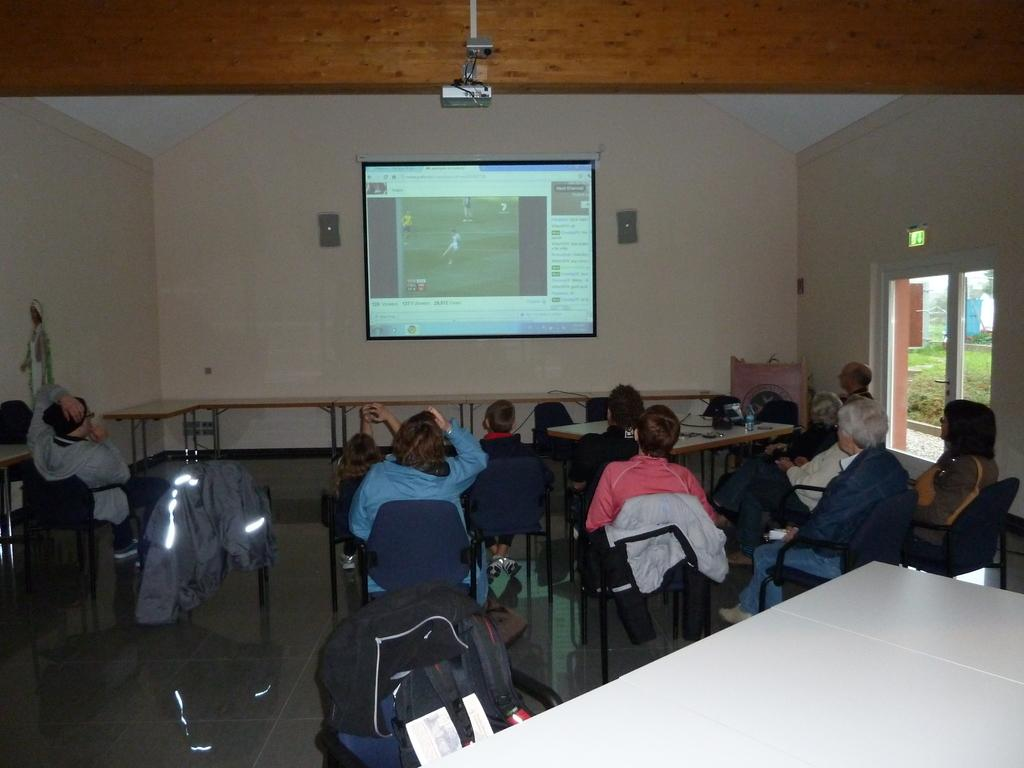What are the people in the image doing? The people in the image are sitting on chairs. What device is present in the image for displaying visuals? There is a projector in the image. What is the purpose of the screen on the wall in the image? The screen on the wall is used to display the visuals projected by the projector. What type of cave can be seen in the background of the image? There is no cave present in the image; it features people sitting on chairs with a projector and a screen on the wall. How many streets are visible in the image? There are no streets visible in the image. 